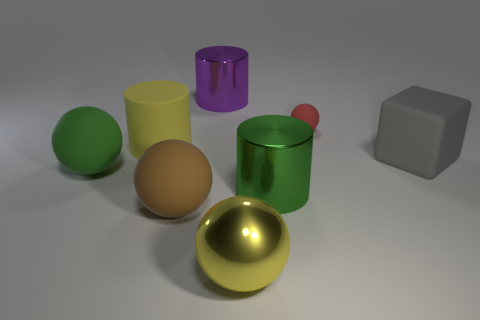What time of day or lighting conditions does the setting imply? The lighting in the image appears to simulate an indoor environment with soft, diffused light possibly coming from multiple sources. This provides soft shadows and subtle highlights on the objects, suggesting an overcast day or a room with well-distributed artificial lighting. 